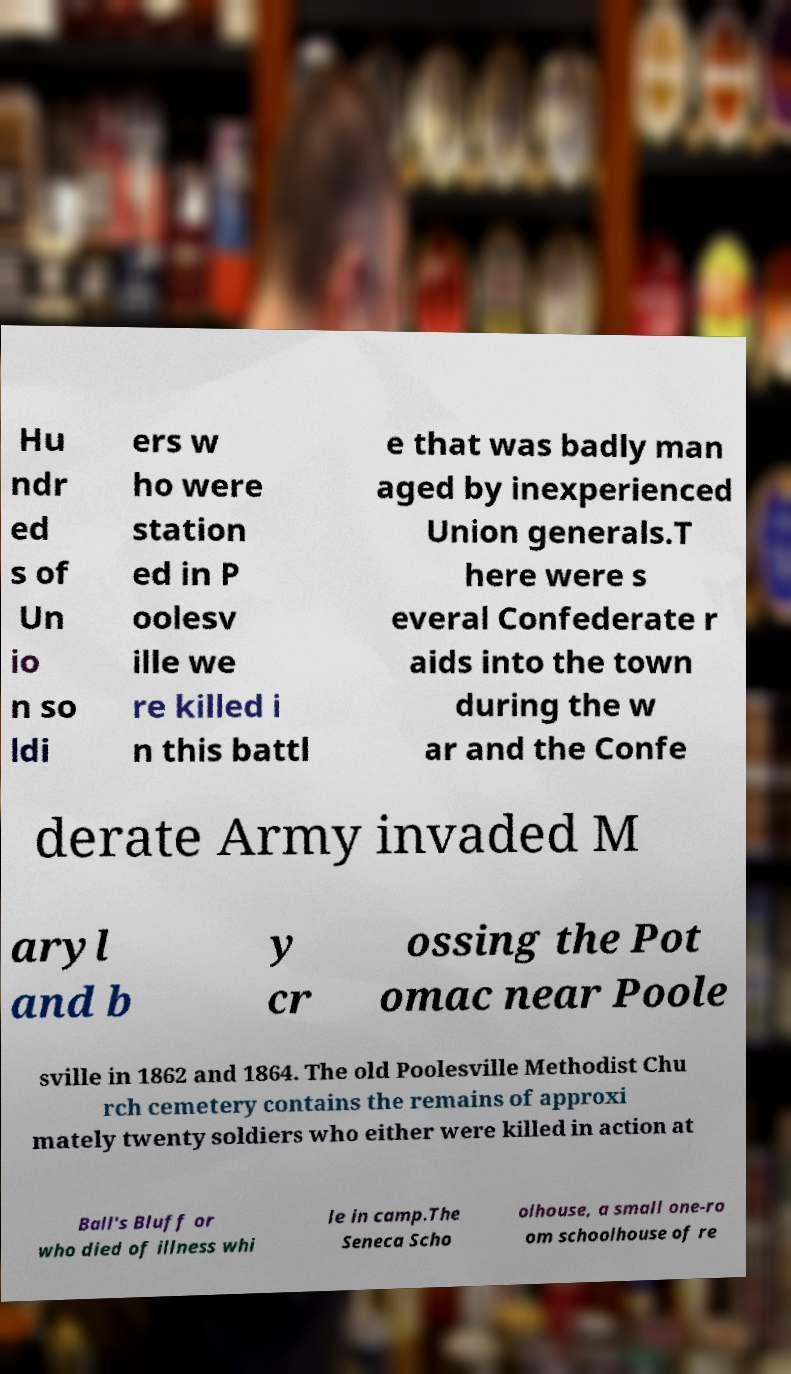For documentation purposes, I need the text within this image transcribed. Could you provide that? Hu ndr ed s of Un io n so ldi ers w ho were station ed in P oolesv ille we re killed i n this battl e that was badly man aged by inexperienced Union generals.T here were s everal Confederate r aids into the town during the w ar and the Confe derate Army invaded M aryl and b y cr ossing the Pot omac near Poole sville in 1862 and 1864. The old Poolesville Methodist Chu rch cemetery contains the remains of approxi mately twenty soldiers who either were killed in action at Ball's Bluff or who died of illness whi le in camp.The Seneca Scho olhouse, a small one-ro om schoolhouse of re 